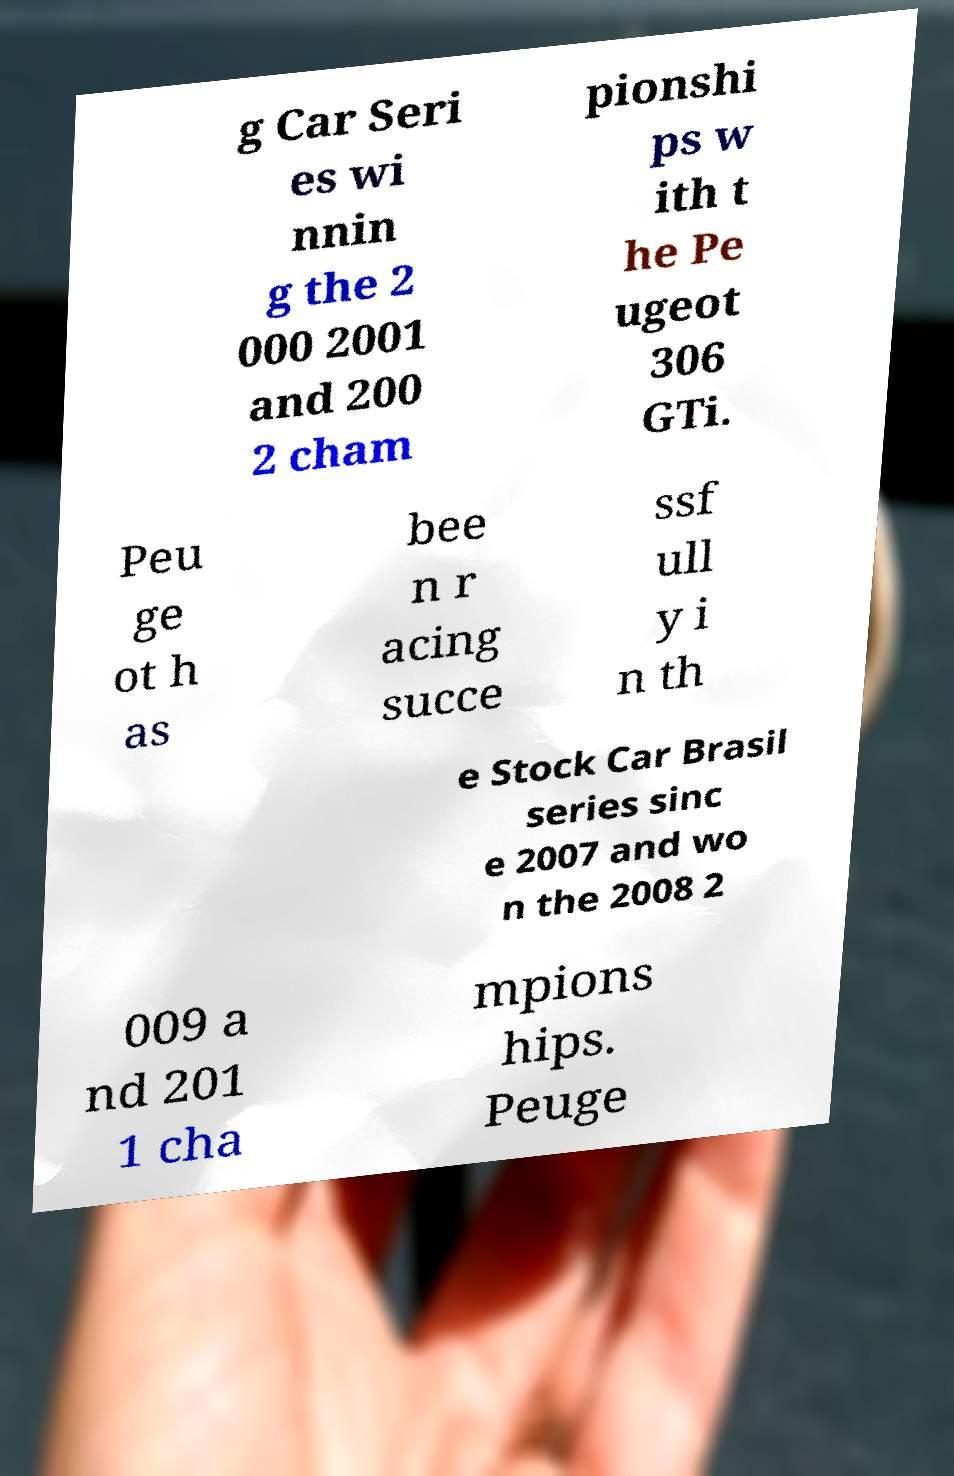Could you extract and type out the text from this image? g Car Seri es wi nnin g the 2 000 2001 and 200 2 cham pionshi ps w ith t he Pe ugeot 306 GTi. Peu ge ot h as bee n r acing succe ssf ull y i n th e Stock Car Brasil series sinc e 2007 and wo n the 2008 2 009 a nd 201 1 cha mpions hips. Peuge 